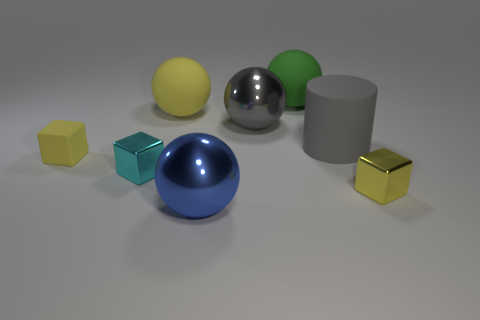What number of cylinders are either red things or tiny yellow matte things?
Make the answer very short. 0. What color is the cylinder that is the same size as the green rubber ball?
Offer a very short reply. Gray. Are there any other things that have the same shape as the large gray matte object?
Provide a succinct answer. No. The other big matte object that is the same shape as the big yellow thing is what color?
Make the answer very short. Green. How many objects are gray rubber things or big objects behind the gray cylinder?
Offer a very short reply. 4. Are there fewer gray objects that are to the left of the large green matte sphere than green matte balls?
Provide a short and direct response. No. What is the size of the yellow thing that is in front of the small yellow block that is on the left side of the yellow rubber thing that is on the right side of the small cyan cube?
Provide a short and direct response. Small. There is a object that is on the right side of the big gray metallic thing and on the left side of the matte cylinder; what color is it?
Keep it short and to the point. Green. How many big yellow cubes are there?
Give a very brief answer. 0. Is there any other thing that is the same size as the yellow rubber ball?
Keep it short and to the point. Yes. 